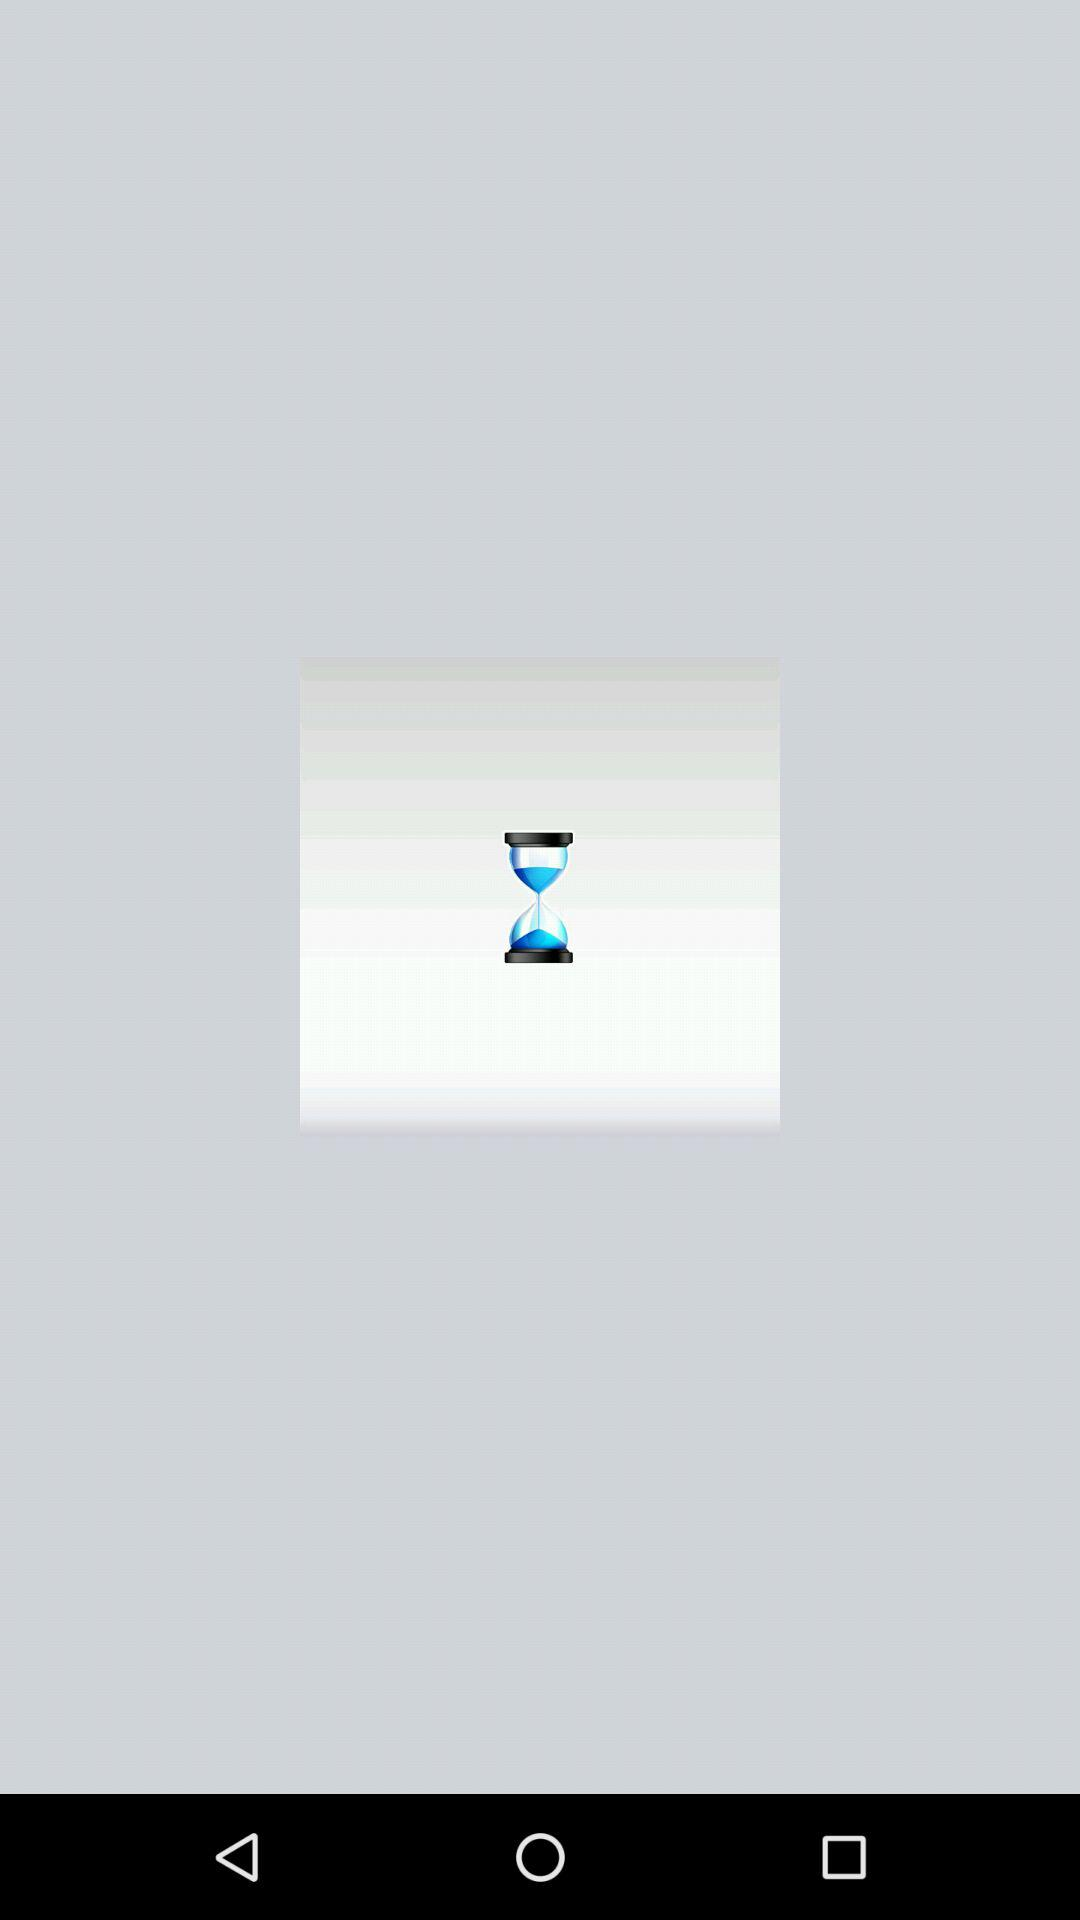How many blue hourglasses are there on the screen?
Answer the question using a single word or phrase. 2 